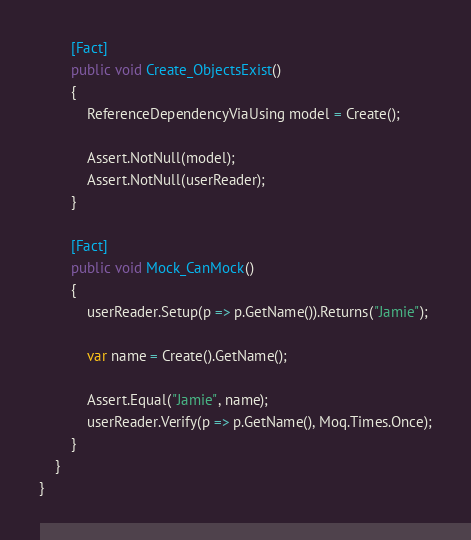Convert code to text. <code><loc_0><loc_0><loc_500><loc_500><_C#_>        [Fact]
        public void Create_ObjectsExist()
        {
            ReferenceDependencyViaUsing model = Create();

            Assert.NotNull(model);
            Assert.NotNull(userReader);
        }

        [Fact]
        public void Mock_CanMock()
        {
            userReader.Setup(p => p.GetName()).Returns("Jamie");

            var name = Create().GetName();

            Assert.Equal("Jamie", name);
            userReader.Verify(p => p.GetName(), Moq.Times.Once);
        }
    }
}</code> 